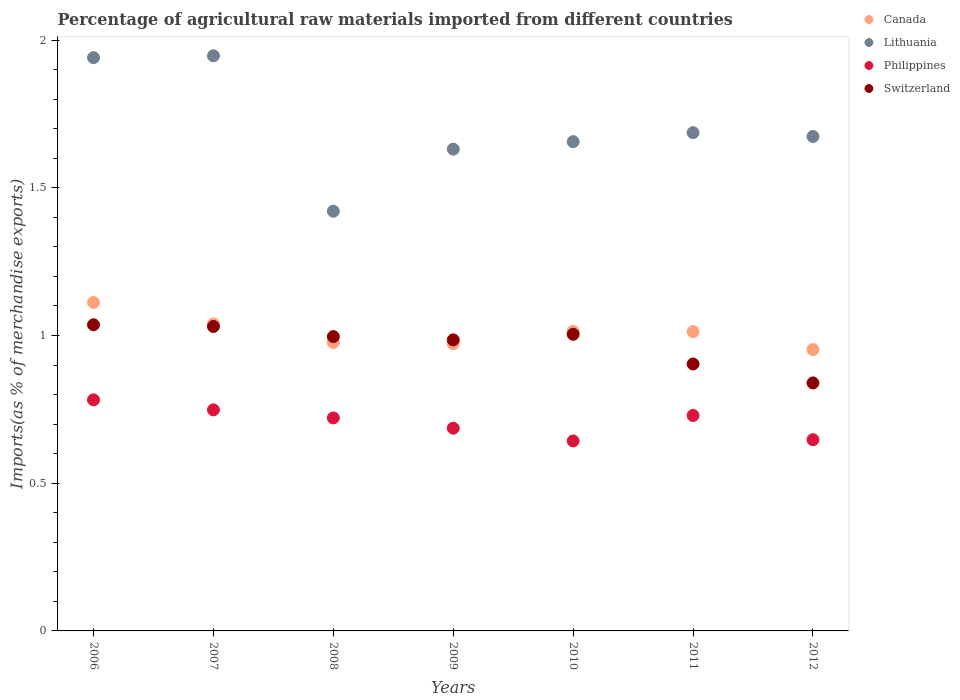How many different coloured dotlines are there?
Your answer should be compact. 4. Is the number of dotlines equal to the number of legend labels?
Provide a short and direct response. Yes. What is the percentage of imports to different countries in Switzerland in 2009?
Your answer should be very brief. 0.99. Across all years, what is the maximum percentage of imports to different countries in Philippines?
Make the answer very short. 0.78. Across all years, what is the minimum percentage of imports to different countries in Lithuania?
Your answer should be very brief. 1.42. In which year was the percentage of imports to different countries in Lithuania maximum?
Provide a short and direct response. 2007. What is the total percentage of imports to different countries in Canada in the graph?
Make the answer very short. 7.08. What is the difference between the percentage of imports to different countries in Lithuania in 2006 and that in 2012?
Provide a short and direct response. 0.27. What is the difference between the percentage of imports to different countries in Switzerland in 2007 and the percentage of imports to different countries in Lithuania in 2008?
Offer a very short reply. -0.39. What is the average percentage of imports to different countries in Philippines per year?
Your answer should be compact. 0.71. In the year 2010, what is the difference between the percentage of imports to different countries in Lithuania and percentage of imports to different countries in Canada?
Provide a succinct answer. 0.64. In how many years, is the percentage of imports to different countries in Canada greater than 1.1 %?
Ensure brevity in your answer.  1. What is the ratio of the percentage of imports to different countries in Canada in 2009 to that in 2010?
Offer a very short reply. 0.96. Is the percentage of imports to different countries in Lithuania in 2011 less than that in 2012?
Your answer should be very brief. No. Is the difference between the percentage of imports to different countries in Lithuania in 2006 and 2010 greater than the difference between the percentage of imports to different countries in Canada in 2006 and 2010?
Keep it short and to the point. Yes. What is the difference between the highest and the second highest percentage of imports to different countries in Switzerland?
Make the answer very short. 0.01. What is the difference between the highest and the lowest percentage of imports to different countries in Philippines?
Your answer should be compact. 0.14. Does the percentage of imports to different countries in Philippines monotonically increase over the years?
Keep it short and to the point. No. Is the percentage of imports to different countries in Philippines strictly less than the percentage of imports to different countries in Switzerland over the years?
Give a very brief answer. Yes. How many dotlines are there?
Your answer should be very brief. 4. How many years are there in the graph?
Keep it short and to the point. 7. What is the difference between two consecutive major ticks on the Y-axis?
Your answer should be compact. 0.5. Are the values on the major ticks of Y-axis written in scientific E-notation?
Provide a succinct answer. No. Does the graph contain any zero values?
Keep it short and to the point. No. Where does the legend appear in the graph?
Provide a succinct answer. Top right. What is the title of the graph?
Offer a terse response. Percentage of agricultural raw materials imported from different countries. Does "Albania" appear as one of the legend labels in the graph?
Your answer should be compact. No. What is the label or title of the Y-axis?
Provide a succinct answer. Imports(as % of merchandise exports). What is the Imports(as % of merchandise exports) in Canada in 2006?
Make the answer very short. 1.11. What is the Imports(as % of merchandise exports) of Lithuania in 2006?
Give a very brief answer. 1.94. What is the Imports(as % of merchandise exports) of Philippines in 2006?
Offer a very short reply. 0.78. What is the Imports(as % of merchandise exports) in Switzerland in 2006?
Offer a terse response. 1.04. What is the Imports(as % of merchandise exports) of Canada in 2007?
Offer a terse response. 1.04. What is the Imports(as % of merchandise exports) of Lithuania in 2007?
Offer a very short reply. 1.95. What is the Imports(as % of merchandise exports) of Philippines in 2007?
Ensure brevity in your answer.  0.75. What is the Imports(as % of merchandise exports) of Switzerland in 2007?
Ensure brevity in your answer.  1.03. What is the Imports(as % of merchandise exports) of Canada in 2008?
Your answer should be compact. 0.98. What is the Imports(as % of merchandise exports) of Lithuania in 2008?
Offer a terse response. 1.42. What is the Imports(as % of merchandise exports) in Philippines in 2008?
Provide a succinct answer. 0.72. What is the Imports(as % of merchandise exports) of Switzerland in 2008?
Your answer should be compact. 1. What is the Imports(as % of merchandise exports) in Canada in 2009?
Your answer should be very brief. 0.97. What is the Imports(as % of merchandise exports) in Lithuania in 2009?
Keep it short and to the point. 1.63. What is the Imports(as % of merchandise exports) of Philippines in 2009?
Provide a succinct answer. 0.69. What is the Imports(as % of merchandise exports) of Switzerland in 2009?
Provide a short and direct response. 0.99. What is the Imports(as % of merchandise exports) in Canada in 2010?
Ensure brevity in your answer.  1.01. What is the Imports(as % of merchandise exports) in Lithuania in 2010?
Make the answer very short. 1.66. What is the Imports(as % of merchandise exports) in Philippines in 2010?
Provide a short and direct response. 0.64. What is the Imports(as % of merchandise exports) in Switzerland in 2010?
Offer a very short reply. 1. What is the Imports(as % of merchandise exports) of Canada in 2011?
Offer a terse response. 1.01. What is the Imports(as % of merchandise exports) in Lithuania in 2011?
Keep it short and to the point. 1.69. What is the Imports(as % of merchandise exports) of Philippines in 2011?
Your response must be concise. 0.73. What is the Imports(as % of merchandise exports) in Switzerland in 2011?
Keep it short and to the point. 0.9. What is the Imports(as % of merchandise exports) of Canada in 2012?
Provide a short and direct response. 0.95. What is the Imports(as % of merchandise exports) of Lithuania in 2012?
Your answer should be very brief. 1.67. What is the Imports(as % of merchandise exports) of Philippines in 2012?
Your response must be concise. 0.65. What is the Imports(as % of merchandise exports) of Switzerland in 2012?
Give a very brief answer. 0.84. Across all years, what is the maximum Imports(as % of merchandise exports) in Canada?
Your answer should be very brief. 1.11. Across all years, what is the maximum Imports(as % of merchandise exports) of Lithuania?
Your answer should be compact. 1.95. Across all years, what is the maximum Imports(as % of merchandise exports) of Philippines?
Provide a succinct answer. 0.78. Across all years, what is the maximum Imports(as % of merchandise exports) in Switzerland?
Offer a very short reply. 1.04. Across all years, what is the minimum Imports(as % of merchandise exports) in Canada?
Offer a terse response. 0.95. Across all years, what is the minimum Imports(as % of merchandise exports) of Lithuania?
Offer a very short reply. 1.42. Across all years, what is the minimum Imports(as % of merchandise exports) of Philippines?
Offer a very short reply. 0.64. Across all years, what is the minimum Imports(as % of merchandise exports) in Switzerland?
Provide a succinct answer. 0.84. What is the total Imports(as % of merchandise exports) in Canada in the graph?
Give a very brief answer. 7.08. What is the total Imports(as % of merchandise exports) in Lithuania in the graph?
Provide a short and direct response. 11.95. What is the total Imports(as % of merchandise exports) in Philippines in the graph?
Keep it short and to the point. 4.96. What is the total Imports(as % of merchandise exports) in Switzerland in the graph?
Your response must be concise. 6.79. What is the difference between the Imports(as % of merchandise exports) in Canada in 2006 and that in 2007?
Provide a short and direct response. 0.07. What is the difference between the Imports(as % of merchandise exports) of Lithuania in 2006 and that in 2007?
Your response must be concise. -0.01. What is the difference between the Imports(as % of merchandise exports) in Philippines in 2006 and that in 2007?
Offer a terse response. 0.03. What is the difference between the Imports(as % of merchandise exports) in Switzerland in 2006 and that in 2007?
Provide a short and direct response. 0.01. What is the difference between the Imports(as % of merchandise exports) of Canada in 2006 and that in 2008?
Keep it short and to the point. 0.14. What is the difference between the Imports(as % of merchandise exports) in Lithuania in 2006 and that in 2008?
Offer a very short reply. 0.52. What is the difference between the Imports(as % of merchandise exports) of Philippines in 2006 and that in 2008?
Offer a very short reply. 0.06. What is the difference between the Imports(as % of merchandise exports) in Switzerland in 2006 and that in 2008?
Make the answer very short. 0.04. What is the difference between the Imports(as % of merchandise exports) of Canada in 2006 and that in 2009?
Keep it short and to the point. 0.14. What is the difference between the Imports(as % of merchandise exports) in Lithuania in 2006 and that in 2009?
Offer a very short reply. 0.31. What is the difference between the Imports(as % of merchandise exports) in Philippines in 2006 and that in 2009?
Your response must be concise. 0.1. What is the difference between the Imports(as % of merchandise exports) of Switzerland in 2006 and that in 2009?
Offer a very short reply. 0.05. What is the difference between the Imports(as % of merchandise exports) of Canada in 2006 and that in 2010?
Your answer should be compact. 0.1. What is the difference between the Imports(as % of merchandise exports) of Lithuania in 2006 and that in 2010?
Provide a succinct answer. 0.28. What is the difference between the Imports(as % of merchandise exports) in Philippines in 2006 and that in 2010?
Keep it short and to the point. 0.14. What is the difference between the Imports(as % of merchandise exports) in Switzerland in 2006 and that in 2010?
Your response must be concise. 0.03. What is the difference between the Imports(as % of merchandise exports) in Canada in 2006 and that in 2011?
Your response must be concise. 0.1. What is the difference between the Imports(as % of merchandise exports) in Lithuania in 2006 and that in 2011?
Offer a very short reply. 0.25. What is the difference between the Imports(as % of merchandise exports) in Philippines in 2006 and that in 2011?
Provide a succinct answer. 0.05. What is the difference between the Imports(as % of merchandise exports) of Switzerland in 2006 and that in 2011?
Offer a very short reply. 0.13. What is the difference between the Imports(as % of merchandise exports) of Canada in 2006 and that in 2012?
Give a very brief answer. 0.16. What is the difference between the Imports(as % of merchandise exports) in Lithuania in 2006 and that in 2012?
Your answer should be very brief. 0.27. What is the difference between the Imports(as % of merchandise exports) in Philippines in 2006 and that in 2012?
Offer a very short reply. 0.13. What is the difference between the Imports(as % of merchandise exports) of Switzerland in 2006 and that in 2012?
Your answer should be compact. 0.2. What is the difference between the Imports(as % of merchandise exports) in Canada in 2007 and that in 2008?
Offer a very short reply. 0.06. What is the difference between the Imports(as % of merchandise exports) in Lithuania in 2007 and that in 2008?
Give a very brief answer. 0.53. What is the difference between the Imports(as % of merchandise exports) in Philippines in 2007 and that in 2008?
Provide a succinct answer. 0.03. What is the difference between the Imports(as % of merchandise exports) in Switzerland in 2007 and that in 2008?
Your answer should be very brief. 0.03. What is the difference between the Imports(as % of merchandise exports) in Canada in 2007 and that in 2009?
Your response must be concise. 0.07. What is the difference between the Imports(as % of merchandise exports) in Lithuania in 2007 and that in 2009?
Offer a terse response. 0.32. What is the difference between the Imports(as % of merchandise exports) of Philippines in 2007 and that in 2009?
Offer a terse response. 0.06. What is the difference between the Imports(as % of merchandise exports) in Switzerland in 2007 and that in 2009?
Provide a short and direct response. 0.05. What is the difference between the Imports(as % of merchandise exports) of Canada in 2007 and that in 2010?
Make the answer very short. 0.03. What is the difference between the Imports(as % of merchandise exports) in Lithuania in 2007 and that in 2010?
Your response must be concise. 0.29. What is the difference between the Imports(as % of merchandise exports) of Philippines in 2007 and that in 2010?
Give a very brief answer. 0.11. What is the difference between the Imports(as % of merchandise exports) of Switzerland in 2007 and that in 2010?
Offer a very short reply. 0.03. What is the difference between the Imports(as % of merchandise exports) in Canada in 2007 and that in 2011?
Provide a succinct answer. 0.03. What is the difference between the Imports(as % of merchandise exports) in Lithuania in 2007 and that in 2011?
Make the answer very short. 0.26. What is the difference between the Imports(as % of merchandise exports) in Philippines in 2007 and that in 2011?
Offer a very short reply. 0.02. What is the difference between the Imports(as % of merchandise exports) of Switzerland in 2007 and that in 2011?
Offer a terse response. 0.13. What is the difference between the Imports(as % of merchandise exports) of Canada in 2007 and that in 2012?
Provide a short and direct response. 0.09. What is the difference between the Imports(as % of merchandise exports) in Lithuania in 2007 and that in 2012?
Keep it short and to the point. 0.27. What is the difference between the Imports(as % of merchandise exports) of Philippines in 2007 and that in 2012?
Your response must be concise. 0.1. What is the difference between the Imports(as % of merchandise exports) of Switzerland in 2007 and that in 2012?
Your response must be concise. 0.19. What is the difference between the Imports(as % of merchandise exports) of Canada in 2008 and that in 2009?
Provide a succinct answer. 0. What is the difference between the Imports(as % of merchandise exports) in Lithuania in 2008 and that in 2009?
Your response must be concise. -0.21. What is the difference between the Imports(as % of merchandise exports) of Philippines in 2008 and that in 2009?
Keep it short and to the point. 0.03. What is the difference between the Imports(as % of merchandise exports) in Switzerland in 2008 and that in 2009?
Ensure brevity in your answer.  0.01. What is the difference between the Imports(as % of merchandise exports) in Canada in 2008 and that in 2010?
Your answer should be very brief. -0.04. What is the difference between the Imports(as % of merchandise exports) in Lithuania in 2008 and that in 2010?
Make the answer very short. -0.24. What is the difference between the Imports(as % of merchandise exports) of Philippines in 2008 and that in 2010?
Ensure brevity in your answer.  0.08. What is the difference between the Imports(as % of merchandise exports) in Switzerland in 2008 and that in 2010?
Offer a very short reply. -0.01. What is the difference between the Imports(as % of merchandise exports) in Canada in 2008 and that in 2011?
Provide a succinct answer. -0.04. What is the difference between the Imports(as % of merchandise exports) of Lithuania in 2008 and that in 2011?
Offer a terse response. -0.27. What is the difference between the Imports(as % of merchandise exports) of Philippines in 2008 and that in 2011?
Make the answer very short. -0.01. What is the difference between the Imports(as % of merchandise exports) in Switzerland in 2008 and that in 2011?
Provide a short and direct response. 0.09. What is the difference between the Imports(as % of merchandise exports) of Canada in 2008 and that in 2012?
Your answer should be very brief. 0.02. What is the difference between the Imports(as % of merchandise exports) of Lithuania in 2008 and that in 2012?
Offer a very short reply. -0.25. What is the difference between the Imports(as % of merchandise exports) of Philippines in 2008 and that in 2012?
Give a very brief answer. 0.07. What is the difference between the Imports(as % of merchandise exports) in Switzerland in 2008 and that in 2012?
Give a very brief answer. 0.16. What is the difference between the Imports(as % of merchandise exports) in Canada in 2009 and that in 2010?
Your response must be concise. -0.04. What is the difference between the Imports(as % of merchandise exports) in Lithuania in 2009 and that in 2010?
Ensure brevity in your answer.  -0.03. What is the difference between the Imports(as % of merchandise exports) in Philippines in 2009 and that in 2010?
Keep it short and to the point. 0.04. What is the difference between the Imports(as % of merchandise exports) of Switzerland in 2009 and that in 2010?
Offer a very short reply. -0.02. What is the difference between the Imports(as % of merchandise exports) of Canada in 2009 and that in 2011?
Your response must be concise. -0.04. What is the difference between the Imports(as % of merchandise exports) of Lithuania in 2009 and that in 2011?
Provide a short and direct response. -0.06. What is the difference between the Imports(as % of merchandise exports) in Philippines in 2009 and that in 2011?
Make the answer very short. -0.04. What is the difference between the Imports(as % of merchandise exports) of Switzerland in 2009 and that in 2011?
Ensure brevity in your answer.  0.08. What is the difference between the Imports(as % of merchandise exports) in Lithuania in 2009 and that in 2012?
Give a very brief answer. -0.04. What is the difference between the Imports(as % of merchandise exports) of Philippines in 2009 and that in 2012?
Make the answer very short. 0.04. What is the difference between the Imports(as % of merchandise exports) in Switzerland in 2009 and that in 2012?
Offer a very short reply. 0.15. What is the difference between the Imports(as % of merchandise exports) of Lithuania in 2010 and that in 2011?
Provide a succinct answer. -0.03. What is the difference between the Imports(as % of merchandise exports) in Philippines in 2010 and that in 2011?
Give a very brief answer. -0.09. What is the difference between the Imports(as % of merchandise exports) in Switzerland in 2010 and that in 2011?
Provide a short and direct response. 0.1. What is the difference between the Imports(as % of merchandise exports) of Canada in 2010 and that in 2012?
Your response must be concise. 0.06. What is the difference between the Imports(as % of merchandise exports) of Lithuania in 2010 and that in 2012?
Your response must be concise. -0.02. What is the difference between the Imports(as % of merchandise exports) in Philippines in 2010 and that in 2012?
Ensure brevity in your answer.  -0. What is the difference between the Imports(as % of merchandise exports) of Switzerland in 2010 and that in 2012?
Offer a very short reply. 0.16. What is the difference between the Imports(as % of merchandise exports) of Canada in 2011 and that in 2012?
Offer a terse response. 0.06. What is the difference between the Imports(as % of merchandise exports) of Lithuania in 2011 and that in 2012?
Provide a succinct answer. 0.01. What is the difference between the Imports(as % of merchandise exports) of Philippines in 2011 and that in 2012?
Give a very brief answer. 0.08. What is the difference between the Imports(as % of merchandise exports) of Switzerland in 2011 and that in 2012?
Your answer should be very brief. 0.06. What is the difference between the Imports(as % of merchandise exports) in Canada in 2006 and the Imports(as % of merchandise exports) in Lithuania in 2007?
Offer a terse response. -0.83. What is the difference between the Imports(as % of merchandise exports) of Canada in 2006 and the Imports(as % of merchandise exports) of Philippines in 2007?
Keep it short and to the point. 0.36. What is the difference between the Imports(as % of merchandise exports) in Canada in 2006 and the Imports(as % of merchandise exports) in Switzerland in 2007?
Your answer should be very brief. 0.08. What is the difference between the Imports(as % of merchandise exports) of Lithuania in 2006 and the Imports(as % of merchandise exports) of Philippines in 2007?
Keep it short and to the point. 1.19. What is the difference between the Imports(as % of merchandise exports) in Lithuania in 2006 and the Imports(as % of merchandise exports) in Switzerland in 2007?
Ensure brevity in your answer.  0.91. What is the difference between the Imports(as % of merchandise exports) in Philippines in 2006 and the Imports(as % of merchandise exports) in Switzerland in 2007?
Make the answer very short. -0.25. What is the difference between the Imports(as % of merchandise exports) in Canada in 2006 and the Imports(as % of merchandise exports) in Lithuania in 2008?
Keep it short and to the point. -0.31. What is the difference between the Imports(as % of merchandise exports) of Canada in 2006 and the Imports(as % of merchandise exports) of Philippines in 2008?
Your response must be concise. 0.39. What is the difference between the Imports(as % of merchandise exports) of Canada in 2006 and the Imports(as % of merchandise exports) of Switzerland in 2008?
Keep it short and to the point. 0.12. What is the difference between the Imports(as % of merchandise exports) in Lithuania in 2006 and the Imports(as % of merchandise exports) in Philippines in 2008?
Give a very brief answer. 1.22. What is the difference between the Imports(as % of merchandise exports) of Lithuania in 2006 and the Imports(as % of merchandise exports) of Switzerland in 2008?
Make the answer very short. 0.94. What is the difference between the Imports(as % of merchandise exports) of Philippines in 2006 and the Imports(as % of merchandise exports) of Switzerland in 2008?
Provide a succinct answer. -0.21. What is the difference between the Imports(as % of merchandise exports) in Canada in 2006 and the Imports(as % of merchandise exports) in Lithuania in 2009?
Make the answer very short. -0.52. What is the difference between the Imports(as % of merchandise exports) in Canada in 2006 and the Imports(as % of merchandise exports) in Philippines in 2009?
Your response must be concise. 0.43. What is the difference between the Imports(as % of merchandise exports) of Canada in 2006 and the Imports(as % of merchandise exports) of Switzerland in 2009?
Offer a terse response. 0.13. What is the difference between the Imports(as % of merchandise exports) in Lithuania in 2006 and the Imports(as % of merchandise exports) in Philippines in 2009?
Your response must be concise. 1.25. What is the difference between the Imports(as % of merchandise exports) in Lithuania in 2006 and the Imports(as % of merchandise exports) in Switzerland in 2009?
Offer a very short reply. 0.96. What is the difference between the Imports(as % of merchandise exports) in Philippines in 2006 and the Imports(as % of merchandise exports) in Switzerland in 2009?
Your response must be concise. -0.2. What is the difference between the Imports(as % of merchandise exports) of Canada in 2006 and the Imports(as % of merchandise exports) of Lithuania in 2010?
Provide a succinct answer. -0.54. What is the difference between the Imports(as % of merchandise exports) in Canada in 2006 and the Imports(as % of merchandise exports) in Philippines in 2010?
Provide a succinct answer. 0.47. What is the difference between the Imports(as % of merchandise exports) in Canada in 2006 and the Imports(as % of merchandise exports) in Switzerland in 2010?
Your response must be concise. 0.11. What is the difference between the Imports(as % of merchandise exports) of Lithuania in 2006 and the Imports(as % of merchandise exports) of Philippines in 2010?
Ensure brevity in your answer.  1.3. What is the difference between the Imports(as % of merchandise exports) of Lithuania in 2006 and the Imports(as % of merchandise exports) of Switzerland in 2010?
Provide a short and direct response. 0.94. What is the difference between the Imports(as % of merchandise exports) of Philippines in 2006 and the Imports(as % of merchandise exports) of Switzerland in 2010?
Your answer should be very brief. -0.22. What is the difference between the Imports(as % of merchandise exports) in Canada in 2006 and the Imports(as % of merchandise exports) in Lithuania in 2011?
Ensure brevity in your answer.  -0.57. What is the difference between the Imports(as % of merchandise exports) of Canada in 2006 and the Imports(as % of merchandise exports) of Philippines in 2011?
Provide a succinct answer. 0.38. What is the difference between the Imports(as % of merchandise exports) of Canada in 2006 and the Imports(as % of merchandise exports) of Switzerland in 2011?
Your response must be concise. 0.21. What is the difference between the Imports(as % of merchandise exports) in Lithuania in 2006 and the Imports(as % of merchandise exports) in Philippines in 2011?
Your answer should be compact. 1.21. What is the difference between the Imports(as % of merchandise exports) of Lithuania in 2006 and the Imports(as % of merchandise exports) of Switzerland in 2011?
Provide a succinct answer. 1.04. What is the difference between the Imports(as % of merchandise exports) in Philippines in 2006 and the Imports(as % of merchandise exports) in Switzerland in 2011?
Your answer should be compact. -0.12. What is the difference between the Imports(as % of merchandise exports) of Canada in 2006 and the Imports(as % of merchandise exports) of Lithuania in 2012?
Your answer should be very brief. -0.56. What is the difference between the Imports(as % of merchandise exports) in Canada in 2006 and the Imports(as % of merchandise exports) in Philippines in 2012?
Your answer should be very brief. 0.46. What is the difference between the Imports(as % of merchandise exports) in Canada in 2006 and the Imports(as % of merchandise exports) in Switzerland in 2012?
Make the answer very short. 0.27. What is the difference between the Imports(as % of merchandise exports) of Lithuania in 2006 and the Imports(as % of merchandise exports) of Philippines in 2012?
Offer a terse response. 1.29. What is the difference between the Imports(as % of merchandise exports) in Lithuania in 2006 and the Imports(as % of merchandise exports) in Switzerland in 2012?
Make the answer very short. 1.1. What is the difference between the Imports(as % of merchandise exports) in Philippines in 2006 and the Imports(as % of merchandise exports) in Switzerland in 2012?
Provide a short and direct response. -0.06. What is the difference between the Imports(as % of merchandise exports) in Canada in 2007 and the Imports(as % of merchandise exports) in Lithuania in 2008?
Your answer should be very brief. -0.38. What is the difference between the Imports(as % of merchandise exports) in Canada in 2007 and the Imports(as % of merchandise exports) in Philippines in 2008?
Provide a short and direct response. 0.32. What is the difference between the Imports(as % of merchandise exports) in Canada in 2007 and the Imports(as % of merchandise exports) in Switzerland in 2008?
Your answer should be compact. 0.04. What is the difference between the Imports(as % of merchandise exports) of Lithuania in 2007 and the Imports(as % of merchandise exports) of Philippines in 2008?
Provide a succinct answer. 1.23. What is the difference between the Imports(as % of merchandise exports) in Lithuania in 2007 and the Imports(as % of merchandise exports) in Switzerland in 2008?
Ensure brevity in your answer.  0.95. What is the difference between the Imports(as % of merchandise exports) of Philippines in 2007 and the Imports(as % of merchandise exports) of Switzerland in 2008?
Provide a succinct answer. -0.25. What is the difference between the Imports(as % of merchandise exports) in Canada in 2007 and the Imports(as % of merchandise exports) in Lithuania in 2009?
Your answer should be compact. -0.59. What is the difference between the Imports(as % of merchandise exports) in Canada in 2007 and the Imports(as % of merchandise exports) in Philippines in 2009?
Make the answer very short. 0.35. What is the difference between the Imports(as % of merchandise exports) in Canada in 2007 and the Imports(as % of merchandise exports) in Switzerland in 2009?
Your answer should be compact. 0.05. What is the difference between the Imports(as % of merchandise exports) in Lithuania in 2007 and the Imports(as % of merchandise exports) in Philippines in 2009?
Offer a terse response. 1.26. What is the difference between the Imports(as % of merchandise exports) of Lithuania in 2007 and the Imports(as % of merchandise exports) of Switzerland in 2009?
Give a very brief answer. 0.96. What is the difference between the Imports(as % of merchandise exports) in Philippines in 2007 and the Imports(as % of merchandise exports) in Switzerland in 2009?
Offer a very short reply. -0.24. What is the difference between the Imports(as % of merchandise exports) in Canada in 2007 and the Imports(as % of merchandise exports) in Lithuania in 2010?
Offer a terse response. -0.62. What is the difference between the Imports(as % of merchandise exports) in Canada in 2007 and the Imports(as % of merchandise exports) in Philippines in 2010?
Your response must be concise. 0.4. What is the difference between the Imports(as % of merchandise exports) of Canada in 2007 and the Imports(as % of merchandise exports) of Switzerland in 2010?
Ensure brevity in your answer.  0.04. What is the difference between the Imports(as % of merchandise exports) of Lithuania in 2007 and the Imports(as % of merchandise exports) of Philippines in 2010?
Provide a succinct answer. 1.3. What is the difference between the Imports(as % of merchandise exports) of Lithuania in 2007 and the Imports(as % of merchandise exports) of Switzerland in 2010?
Make the answer very short. 0.94. What is the difference between the Imports(as % of merchandise exports) in Philippines in 2007 and the Imports(as % of merchandise exports) in Switzerland in 2010?
Your response must be concise. -0.26. What is the difference between the Imports(as % of merchandise exports) of Canada in 2007 and the Imports(as % of merchandise exports) of Lithuania in 2011?
Your response must be concise. -0.65. What is the difference between the Imports(as % of merchandise exports) in Canada in 2007 and the Imports(as % of merchandise exports) in Philippines in 2011?
Offer a terse response. 0.31. What is the difference between the Imports(as % of merchandise exports) of Canada in 2007 and the Imports(as % of merchandise exports) of Switzerland in 2011?
Offer a very short reply. 0.14. What is the difference between the Imports(as % of merchandise exports) in Lithuania in 2007 and the Imports(as % of merchandise exports) in Philippines in 2011?
Offer a very short reply. 1.22. What is the difference between the Imports(as % of merchandise exports) in Lithuania in 2007 and the Imports(as % of merchandise exports) in Switzerland in 2011?
Your answer should be compact. 1.04. What is the difference between the Imports(as % of merchandise exports) of Philippines in 2007 and the Imports(as % of merchandise exports) of Switzerland in 2011?
Offer a very short reply. -0.16. What is the difference between the Imports(as % of merchandise exports) in Canada in 2007 and the Imports(as % of merchandise exports) in Lithuania in 2012?
Provide a succinct answer. -0.63. What is the difference between the Imports(as % of merchandise exports) in Canada in 2007 and the Imports(as % of merchandise exports) in Philippines in 2012?
Offer a very short reply. 0.39. What is the difference between the Imports(as % of merchandise exports) in Canada in 2007 and the Imports(as % of merchandise exports) in Switzerland in 2012?
Provide a succinct answer. 0.2. What is the difference between the Imports(as % of merchandise exports) of Lithuania in 2007 and the Imports(as % of merchandise exports) of Philippines in 2012?
Keep it short and to the point. 1.3. What is the difference between the Imports(as % of merchandise exports) of Lithuania in 2007 and the Imports(as % of merchandise exports) of Switzerland in 2012?
Provide a succinct answer. 1.11. What is the difference between the Imports(as % of merchandise exports) of Philippines in 2007 and the Imports(as % of merchandise exports) of Switzerland in 2012?
Your response must be concise. -0.09. What is the difference between the Imports(as % of merchandise exports) in Canada in 2008 and the Imports(as % of merchandise exports) in Lithuania in 2009?
Provide a short and direct response. -0.65. What is the difference between the Imports(as % of merchandise exports) in Canada in 2008 and the Imports(as % of merchandise exports) in Philippines in 2009?
Provide a succinct answer. 0.29. What is the difference between the Imports(as % of merchandise exports) in Canada in 2008 and the Imports(as % of merchandise exports) in Switzerland in 2009?
Offer a terse response. -0.01. What is the difference between the Imports(as % of merchandise exports) in Lithuania in 2008 and the Imports(as % of merchandise exports) in Philippines in 2009?
Provide a short and direct response. 0.73. What is the difference between the Imports(as % of merchandise exports) in Lithuania in 2008 and the Imports(as % of merchandise exports) in Switzerland in 2009?
Offer a terse response. 0.44. What is the difference between the Imports(as % of merchandise exports) of Philippines in 2008 and the Imports(as % of merchandise exports) of Switzerland in 2009?
Provide a short and direct response. -0.26. What is the difference between the Imports(as % of merchandise exports) of Canada in 2008 and the Imports(as % of merchandise exports) of Lithuania in 2010?
Ensure brevity in your answer.  -0.68. What is the difference between the Imports(as % of merchandise exports) in Canada in 2008 and the Imports(as % of merchandise exports) in Switzerland in 2010?
Ensure brevity in your answer.  -0.03. What is the difference between the Imports(as % of merchandise exports) in Lithuania in 2008 and the Imports(as % of merchandise exports) in Philippines in 2010?
Give a very brief answer. 0.78. What is the difference between the Imports(as % of merchandise exports) of Lithuania in 2008 and the Imports(as % of merchandise exports) of Switzerland in 2010?
Provide a short and direct response. 0.42. What is the difference between the Imports(as % of merchandise exports) of Philippines in 2008 and the Imports(as % of merchandise exports) of Switzerland in 2010?
Make the answer very short. -0.28. What is the difference between the Imports(as % of merchandise exports) of Canada in 2008 and the Imports(as % of merchandise exports) of Lithuania in 2011?
Offer a very short reply. -0.71. What is the difference between the Imports(as % of merchandise exports) of Canada in 2008 and the Imports(as % of merchandise exports) of Philippines in 2011?
Give a very brief answer. 0.25. What is the difference between the Imports(as % of merchandise exports) in Canada in 2008 and the Imports(as % of merchandise exports) in Switzerland in 2011?
Offer a terse response. 0.07. What is the difference between the Imports(as % of merchandise exports) of Lithuania in 2008 and the Imports(as % of merchandise exports) of Philippines in 2011?
Your response must be concise. 0.69. What is the difference between the Imports(as % of merchandise exports) of Lithuania in 2008 and the Imports(as % of merchandise exports) of Switzerland in 2011?
Offer a terse response. 0.52. What is the difference between the Imports(as % of merchandise exports) in Philippines in 2008 and the Imports(as % of merchandise exports) in Switzerland in 2011?
Keep it short and to the point. -0.18. What is the difference between the Imports(as % of merchandise exports) of Canada in 2008 and the Imports(as % of merchandise exports) of Lithuania in 2012?
Ensure brevity in your answer.  -0.7. What is the difference between the Imports(as % of merchandise exports) in Canada in 2008 and the Imports(as % of merchandise exports) in Philippines in 2012?
Give a very brief answer. 0.33. What is the difference between the Imports(as % of merchandise exports) in Canada in 2008 and the Imports(as % of merchandise exports) in Switzerland in 2012?
Provide a succinct answer. 0.14. What is the difference between the Imports(as % of merchandise exports) in Lithuania in 2008 and the Imports(as % of merchandise exports) in Philippines in 2012?
Offer a very short reply. 0.77. What is the difference between the Imports(as % of merchandise exports) in Lithuania in 2008 and the Imports(as % of merchandise exports) in Switzerland in 2012?
Your answer should be very brief. 0.58. What is the difference between the Imports(as % of merchandise exports) of Philippines in 2008 and the Imports(as % of merchandise exports) of Switzerland in 2012?
Give a very brief answer. -0.12. What is the difference between the Imports(as % of merchandise exports) in Canada in 2009 and the Imports(as % of merchandise exports) in Lithuania in 2010?
Ensure brevity in your answer.  -0.68. What is the difference between the Imports(as % of merchandise exports) of Canada in 2009 and the Imports(as % of merchandise exports) of Philippines in 2010?
Offer a terse response. 0.33. What is the difference between the Imports(as % of merchandise exports) of Canada in 2009 and the Imports(as % of merchandise exports) of Switzerland in 2010?
Provide a succinct answer. -0.03. What is the difference between the Imports(as % of merchandise exports) in Lithuania in 2009 and the Imports(as % of merchandise exports) in Switzerland in 2010?
Give a very brief answer. 0.63. What is the difference between the Imports(as % of merchandise exports) of Philippines in 2009 and the Imports(as % of merchandise exports) of Switzerland in 2010?
Your response must be concise. -0.32. What is the difference between the Imports(as % of merchandise exports) in Canada in 2009 and the Imports(as % of merchandise exports) in Lithuania in 2011?
Make the answer very short. -0.71. What is the difference between the Imports(as % of merchandise exports) of Canada in 2009 and the Imports(as % of merchandise exports) of Philippines in 2011?
Give a very brief answer. 0.24. What is the difference between the Imports(as % of merchandise exports) in Canada in 2009 and the Imports(as % of merchandise exports) in Switzerland in 2011?
Ensure brevity in your answer.  0.07. What is the difference between the Imports(as % of merchandise exports) of Lithuania in 2009 and the Imports(as % of merchandise exports) of Philippines in 2011?
Ensure brevity in your answer.  0.9. What is the difference between the Imports(as % of merchandise exports) in Lithuania in 2009 and the Imports(as % of merchandise exports) in Switzerland in 2011?
Keep it short and to the point. 0.73. What is the difference between the Imports(as % of merchandise exports) of Philippines in 2009 and the Imports(as % of merchandise exports) of Switzerland in 2011?
Make the answer very short. -0.22. What is the difference between the Imports(as % of merchandise exports) of Canada in 2009 and the Imports(as % of merchandise exports) of Lithuania in 2012?
Offer a terse response. -0.7. What is the difference between the Imports(as % of merchandise exports) of Canada in 2009 and the Imports(as % of merchandise exports) of Philippines in 2012?
Ensure brevity in your answer.  0.33. What is the difference between the Imports(as % of merchandise exports) of Canada in 2009 and the Imports(as % of merchandise exports) of Switzerland in 2012?
Provide a succinct answer. 0.13. What is the difference between the Imports(as % of merchandise exports) of Lithuania in 2009 and the Imports(as % of merchandise exports) of Philippines in 2012?
Provide a short and direct response. 0.98. What is the difference between the Imports(as % of merchandise exports) of Lithuania in 2009 and the Imports(as % of merchandise exports) of Switzerland in 2012?
Provide a short and direct response. 0.79. What is the difference between the Imports(as % of merchandise exports) in Philippines in 2009 and the Imports(as % of merchandise exports) in Switzerland in 2012?
Your answer should be compact. -0.15. What is the difference between the Imports(as % of merchandise exports) in Canada in 2010 and the Imports(as % of merchandise exports) in Lithuania in 2011?
Your answer should be compact. -0.67. What is the difference between the Imports(as % of merchandise exports) in Canada in 2010 and the Imports(as % of merchandise exports) in Philippines in 2011?
Provide a succinct answer. 0.28. What is the difference between the Imports(as % of merchandise exports) of Canada in 2010 and the Imports(as % of merchandise exports) of Switzerland in 2011?
Make the answer very short. 0.11. What is the difference between the Imports(as % of merchandise exports) of Lithuania in 2010 and the Imports(as % of merchandise exports) of Philippines in 2011?
Your response must be concise. 0.93. What is the difference between the Imports(as % of merchandise exports) in Lithuania in 2010 and the Imports(as % of merchandise exports) in Switzerland in 2011?
Offer a terse response. 0.75. What is the difference between the Imports(as % of merchandise exports) of Philippines in 2010 and the Imports(as % of merchandise exports) of Switzerland in 2011?
Make the answer very short. -0.26. What is the difference between the Imports(as % of merchandise exports) of Canada in 2010 and the Imports(as % of merchandise exports) of Lithuania in 2012?
Your answer should be compact. -0.66. What is the difference between the Imports(as % of merchandise exports) in Canada in 2010 and the Imports(as % of merchandise exports) in Philippines in 2012?
Your response must be concise. 0.37. What is the difference between the Imports(as % of merchandise exports) in Canada in 2010 and the Imports(as % of merchandise exports) in Switzerland in 2012?
Your answer should be very brief. 0.17. What is the difference between the Imports(as % of merchandise exports) of Lithuania in 2010 and the Imports(as % of merchandise exports) of Philippines in 2012?
Offer a very short reply. 1.01. What is the difference between the Imports(as % of merchandise exports) of Lithuania in 2010 and the Imports(as % of merchandise exports) of Switzerland in 2012?
Your answer should be compact. 0.82. What is the difference between the Imports(as % of merchandise exports) of Philippines in 2010 and the Imports(as % of merchandise exports) of Switzerland in 2012?
Offer a terse response. -0.2. What is the difference between the Imports(as % of merchandise exports) of Canada in 2011 and the Imports(as % of merchandise exports) of Lithuania in 2012?
Ensure brevity in your answer.  -0.66. What is the difference between the Imports(as % of merchandise exports) of Canada in 2011 and the Imports(as % of merchandise exports) of Philippines in 2012?
Offer a very short reply. 0.37. What is the difference between the Imports(as % of merchandise exports) in Canada in 2011 and the Imports(as % of merchandise exports) in Switzerland in 2012?
Offer a terse response. 0.17. What is the difference between the Imports(as % of merchandise exports) of Lithuania in 2011 and the Imports(as % of merchandise exports) of Philippines in 2012?
Provide a short and direct response. 1.04. What is the difference between the Imports(as % of merchandise exports) of Lithuania in 2011 and the Imports(as % of merchandise exports) of Switzerland in 2012?
Give a very brief answer. 0.85. What is the difference between the Imports(as % of merchandise exports) of Philippines in 2011 and the Imports(as % of merchandise exports) of Switzerland in 2012?
Your response must be concise. -0.11. What is the average Imports(as % of merchandise exports) of Canada per year?
Provide a short and direct response. 1.01. What is the average Imports(as % of merchandise exports) in Lithuania per year?
Provide a short and direct response. 1.71. What is the average Imports(as % of merchandise exports) of Philippines per year?
Ensure brevity in your answer.  0.71. What is the average Imports(as % of merchandise exports) of Switzerland per year?
Your answer should be very brief. 0.97. In the year 2006, what is the difference between the Imports(as % of merchandise exports) of Canada and Imports(as % of merchandise exports) of Lithuania?
Make the answer very short. -0.83. In the year 2006, what is the difference between the Imports(as % of merchandise exports) in Canada and Imports(as % of merchandise exports) in Philippines?
Give a very brief answer. 0.33. In the year 2006, what is the difference between the Imports(as % of merchandise exports) in Canada and Imports(as % of merchandise exports) in Switzerland?
Offer a terse response. 0.08. In the year 2006, what is the difference between the Imports(as % of merchandise exports) in Lithuania and Imports(as % of merchandise exports) in Philippines?
Ensure brevity in your answer.  1.16. In the year 2006, what is the difference between the Imports(as % of merchandise exports) in Lithuania and Imports(as % of merchandise exports) in Switzerland?
Keep it short and to the point. 0.9. In the year 2006, what is the difference between the Imports(as % of merchandise exports) in Philippines and Imports(as % of merchandise exports) in Switzerland?
Offer a very short reply. -0.25. In the year 2007, what is the difference between the Imports(as % of merchandise exports) of Canada and Imports(as % of merchandise exports) of Lithuania?
Give a very brief answer. -0.91. In the year 2007, what is the difference between the Imports(as % of merchandise exports) of Canada and Imports(as % of merchandise exports) of Philippines?
Your answer should be very brief. 0.29. In the year 2007, what is the difference between the Imports(as % of merchandise exports) of Canada and Imports(as % of merchandise exports) of Switzerland?
Provide a succinct answer. 0.01. In the year 2007, what is the difference between the Imports(as % of merchandise exports) of Lithuania and Imports(as % of merchandise exports) of Philippines?
Your answer should be very brief. 1.2. In the year 2007, what is the difference between the Imports(as % of merchandise exports) of Lithuania and Imports(as % of merchandise exports) of Switzerland?
Your answer should be compact. 0.92. In the year 2007, what is the difference between the Imports(as % of merchandise exports) of Philippines and Imports(as % of merchandise exports) of Switzerland?
Provide a succinct answer. -0.28. In the year 2008, what is the difference between the Imports(as % of merchandise exports) of Canada and Imports(as % of merchandise exports) of Lithuania?
Offer a terse response. -0.44. In the year 2008, what is the difference between the Imports(as % of merchandise exports) of Canada and Imports(as % of merchandise exports) of Philippines?
Provide a short and direct response. 0.26. In the year 2008, what is the difference between the Imports(as % of merchandise exports) of Canada and Imports(as % of merchandise exports) of Switzerland?
Keep it short and to the point. -0.02. In the year 2008, what is the difference between the Imports(as % of merchandise exports) of Lithuania and Imports(as % of merchandise exports) of Philippines?
Offer a very short reply. 0.7. In the year 2008, what is the difference between the Imports(as % of merchandise exports) in Lithuania and Imports(as % of merchandise exports) in Switzerland?
Provide a short and direct response. 0.42. In the year 2008, what is the difference between the Imports(as % of merchandise exports) of Philippines and Imports(as % of merchandise exports) of Switzerland?
Your response must be concise. -0.28. In the year 2009, what is the difference between the Imports(as % of merchandise exports) in Canada and Imports(as % of merchandise exports) in Lithuania?
Offer a very short reply. -0.66. In the year 2009, what is the difference between the Imports(as % of merchandise exports) of Canada and Imports(as % of merchandise exports) of Philippines?
Give a very brief answer. 0.29. In the year 2009, what is the difference between the Imports(as % of merchandise exports) in Canada and Imports(as % of merchandise exports) in Switzerland?
Ensure brevity in your answer.  -0.01. In the year 2009, what is the difference between the Imports(as % of merchandise exports) of Lithuania and Imports(as % of merchandise exports) of Philippines?
Your answer should be very brief. 0.94. In the year 2009, what is the difference between the Imports(as % of merchandise exports) in Lithuania and Imports(as % of merchandise exports) in Switzerland?
Offer a terse response. 0.65. In the year 2009, what is the difference between the Imports(as % of merchandise exports) of Philippines and Imports(as % of merchandise exports) of Switzerland?
Offer a very short reply. -0.3. In the year 2010, what is the difference between the Imports(as % of merchandise exports) in Canada and Imports(as % of merchandise exports) in Lithuania?
Ensure brevity in your answer.  -0.64. In the year 2010, what is the difference between the Imports(as % of merchandise exports) of Canada and Imports(as % of merchandise exports) of Philippines?
Keep it short and to the point. 0.37. In the year 2010, what is the difference between the Imports(as % of merchandise exports) in Canada and Imports(as % of merchandise exports) in Switzerland?
Ensure brevity in your answer.  0.01. In the year 2010, what is the difference between the Imports(as % of merchandise exports) in Lithuania and Imports(as % of merchandise exports) in Switzerland?
Provide a short and direct response. 0.65. In the year 2010, what is the difference between the Imports(as % of merchandise exports) in Philippines and Imports(as % of merchandise exports) in Switzerland?
Provide a short and direct response. -0.36. In the year 2011, what is the difference between the Imports(as % of merchandise exports) in Canada and Imports(as % of merchandise exports) in Lithuania?
Give a very brief answer. -0.67. In the year 2011, what is the difference between the Imports(as % of merchandise exports) of Canada and Imports(as % of merchandise exports) of Philippines?
Offer a terse response. 0.28. In the year 2011, what is the difference between the Imports(as % of merchandise exports) of Canada and Imports(as % of merchandise exports) of Switzerland?
Offer a very short reply. 0.11. In the year 2011, what is the difference between the Imports(as % of merchandise exports) of Lithuania and Imports(as % of merchandise exports) of Philippines?
Provide a succinct answer. 0.96. In the year 2011, what is the difference between the Imports(as % of merchandise exports) in Lithuania and Imports(as % of merchandise exports) in Switzerland?
Give a very brief answer. 0.78. In the year 2011, what is the difference between the Imports(as % of merchandise exports) in Philippines and Imports(as % of merchandise exports) in Switzerland?
Keep it short and to the point. -0.17. In the year 2012, what is the difference between the Imports(as % of merchandise exports) of Canada and Imports(as % of merchandise exports) of Lithuania?
Offer a terse response. -0.72. In the year 2012, what is the difference between the Imports(as % of merchandise exports) in Canada and Imports(as % of merchandise exports) in Philippines?
Provide a short and direct response. 0.3. In the year 2012, what is the difference between the Imports(as % of merchandise exports) of Canada and Imports(as % of merchandise exports) of Switzerland?
Offer a terse response. 0.11. In the year 2012, what is the difference between the Imports(as % of merchandise exports) in Lithuania and Imports(as % of merchandise exports) in Philippines?
Make the answer very short. 1.03. In the year 2012, what is the difference between the Imports(as % of merchandise exports) of Lithuania and Imports(as % of merchandise exports) of Switzerland?
Give a very brief answer. 0.83. In the year 2012, what is the difference between the Imports(as % of merchandise exports) of Philippines and Imports(as % of merchandise exports) of Switzerland?
Your answer should be very brief. -0.19. What is the ratio of the Imports(as % of merchandise exports) of Canada in 2006 to that in 2007?
Give a very brief answer. 1.07. What is the ratio of the Imports(as % of merchandise exports) of Philippines in 2006 to that in 2007?
Offer a very short reply. 1.05. What is the ratio of the Imports(as % of merchandise exports) of Switzerland in 2006 to that in 2007?
Give a very brief answer. 1.01. What is the ratio of the Imports(as % of merchandise exports) of Canada in 2006 to that in 2008?
Ensure brevity in your answer.  1.14. What is the ratio of the Imports(as % of merchandise exports) of Lithuania in 2006 to that in 2008?
Offer a terse response. 1.37. What is the ratio of the Imports(as % of merchandise exports) in Philippines in 2006 to that in 2008?
Make the answer very short. 1.08. What is the ratio of the Imports(as % of merchandise exports) of Switzerland in 2006 to that in 2008?
Ensure brevity in your answer.  1.04. What is the ratio of the Imports(as % of merchandise exports) of Canada in 2006 to that in 2009?
Ensure brevity in your answer.  1.14. What is the ratio of the Imports(as % of merchandise exports) of Lithuania in 2006 to that in 2009?
Give a very brief answer. 1.19. What is the ratio of the Imports(as % of merchandise exports) of Philippines in 2006 to that in 2009?
Provide a short and direct response. 1.14. What is the ratio of the Imports(as % of merchandise exports) of Switzerland in 2006 to that in 2009?
Your response must be concise. 1.05. What is the ratio of the Imports(as % of merchandise exports) in Canada in 2006 to that in 2010?
Ensure brevity in your answer.  1.1. What is the ratio of the Imports(as % of merchandise exports) of Lithuania in 2006 to that in 2010?
Keep it short and to the point. 1.17. What is the ratio of the Imports(as % of merchandise exports) in Philippines in 2006 to that in 2010?
Provide a succinct answer. 1.22. What is the ratio of the Imports(as % of merchandise exports) of Switzerland in 2006 to that in 2010?
Your response must be concise. 1.03. What is the ratio of the Imports(as % of merchandise exports) in Canada in 2006 to that in 2011?
Offer a terse response. 1.1. What is the ratio of the Imports(as % of merchandise exports) of Lithuania in 2006 to that in 2011?
Provide a succinct answer. 1.15. What is the ratio of the Imports(as % of merchandise exports) in Philippines in 2006 to that in 2011?
Provide a short and direct response. 1.07. What is the ratio of the Imports(as % of merchandise exports) in Switzerland in 2006 to that in 2011?
Ensure brevity in your answer.  1.15. What is the ratio of the Imports(as % of merchandise exports) in Canada in 2006 to that in 2012?
Give a very brief answer. 1.17. What is the ratio of the Imports(as % of merchandise exports) of Lithuania in 2006 to that in 2012?
Offer a terse response. 1.16. What is the ratio of the Imports(as % of merchandise exports) in Philippines in 2006 to that in 2012?
Offer a very short reply. 1.21. What is the ratio of the Imports(as % of merchandise exports) in Switzerland in 2006 to that in 2012?
Offer a terse response. 1.23. What is the ratio of the Imports(as % of merchandise exports) in Canada in 2007 to that in 2008?
Provide a succinct answer. 1.06. What is the ratio of the Imports(as % of merchandise exports) of Lithuania in 2007 to that in 2008?
Make the answer very short. 1.37. What is the ratio of the Imports(as % of merchandise exports) in Philippines in 2007 to that in 2008?
Offer a terse response. 1.04. What is the ratio of the Imports(as % of merchandise exports) in Switzerland in 2007 to that in 2008?
Provide a succinct answer. 1.03. What is the ratio of the Imports(as % of merchandise exports) of Canada in 2007 to that in 2009?
Offer a terse response. 1.07. What is the ratio of the Imports(as % of merchandise exports) in Lithuania in 2007 to that in 2009?
Offer a very short reply. 1.19. What is the ratio of the Imports(as % of merchandise exports) in Philippines in 2007 to that in 2009?
Ensure brevity in your answer.  1.09. What is the ratio of the Imports(as % of merchandise exports) of Switzerland in 2007 to that in 2009?
Provide a short and direct response. 1.05. What is the ratio of the Imports(as % of merchandise exports) of Canada in 2007 to that in 2010?
Your answer should be very brief. 1.02. What is the ratio of the Imports(as % of merchandise exports) of Lithuania in 2007 to that in 2010?
Offer a terse response. 1.18. What is the ratio of the Imports(as % of merchandise exports) of Philippines in 2007 to that in 2010?
Give a very brief answer. 1.16. What is the ratio of the Imports(as % of merchandise exports) in Switzerland in 2007 to that in 2010?
Make the answer very short. 1.03. What is the ratio of the Imports(as % of merchandise exports) in Canada in 2007 to that in 2011?
Provide a succinct answer. 1.03. What is the ratio of the Imports(as % of merchandise exports) of Lithuania in 2007 to that in 2011?
Your answer should be compact. 1.15. What is the ratio of the Imports(as % of merchandise exports) of Philippines in 2007 to that in 2011?
Offer a terse response. 1.03. What is the ratio of the Imports(as % of merchandise exports) in Switzerland in 2007 to that in 2011?
Make the answer very short. 1.14. What is the ratio of the Imports(as % of merchandise exports) of Canada in 2007 to that in 2012?
Your answer should be compact. 1.09. What is the ratio of the Imports(as % of merchandise exports) of Lithuania in 2007 to that in 2012?
Your answer should be compact. 1.16. What is the ratio of the Imports(as % of merchandise exports) of Philippines in 2007 to that in 2012?
Keep it short and to the point. 1.16. What is the ratio of the Imports(as % of merchandise exports) in Switzerland in 2007 to that in 2012?
Provide a succinct answer. 1.23. What is the ratio of the Imports(as % of merchandise exports) of Lithuania in 2008 to that in 2009?
Provide a succinct answer. 0.87. What is the ratio of the Imports(as % of merchandise exports) of Philippines in 2008 to that in 2009?
Keep it short and to the point. 1.05. What is the ratio of the Imports(as % of merchandise exports) in Switzerland in 2008 to that in 2009?
Your response must be concise. 1.01. What is the ratio of the Imports(as % of merchandise exports) of Lithuania in 2008 to that in 2010?
Give a very brief answer. 0.86. What is the ratio of the Imports(as % of merchandise exports) of Philippines in 2008 to that in 2010?
Provide a succinct answer. 1.12. What is the ratio of the Imports(as % of merchandise exports) of Canada in 2008 to that in 2011?
Make the answer very short. 0.96. What is the ratio of the Imports(as % of merchandise exports) in Lithuania in 2008 to that in 2011?
Ensure brevity in your answer.  0.84. What is the ratio of the Imports(as % of merchandise exports) of Philippines in 2008 to that in 2011?
Offer a terse response. 0.99. What is the ratio of the Imports(as % of merchandise exports) in Switzerland in 2008 to that in 2011?
Make the answer very short. 1.1. What is the ratio of the Imports(as % of merchandise exports) in Canada in 2008 to that in 2012?
Your answer should be very brief. 1.03. What is the ratio of the Imports(as % of merchandise exports) in Lithuania in 2008 to that in 2012?
Your answer should be compact. 0.85. What is the ratio of the Imports(as % of merchandise exports) in Philippines in 2008 to that in 2012?
Keep it short and to the point. 1.11. What is the ratio of the Imports(as % of merchandise exports) in Switzerland in 2008 to that in 2012?
Ensure brevity in your answer.  1.19. What is the ratio of the Imports(as % of merchandise exports) in Canada in 2009 to that in 2010?
Offer a very short reply. 0.96. What is the ratio of the Imports(as % of merchandise exports) in Lithuania in 2009 to that in 2010?
Offer a terse response. 0.98. What is the ratio of the Imports(as % of merchandise exports) of Philippines in 2009 to that in 2010?
Your answer should be compact. 1.07. What is the ratio of the Imports(as % of merchandise exports) of Switzerland in 2009 to that in 2010?
Keep it short and to the point. 0.98. What is the ratio of the Imports(as % of merchandise exports) of Lithuania in 2009 to that in 2011?
Provide a short and direct response. 0.97. What is the ratio of the Imports(as % of merchandise exports) of Philippines in 2009 to that in 2011?
Offer a very short reply. 0.94. What is the ratio of the Imports(as % of merchandise exports) in Switzerland in 2009 to that in 2011?
Provide a succinct answer. 1.09. What is the ratio of the Imports(as % of merchandise exports) in Canada in 2009 to that in 2012?
Your answer should be very brief. 1.02. What is the ratio of the Imports(as % of merchandise exports) of Lithuania in 2009 to that in 2012?
Make the answer very short. 0.97. What is the ratio of the Imports(as % of merchandise exports) in Philippines in 2009 to that in 2012?
Your response must be concise. 1.06. What is the ratio of the Imports(as % of merchandise exports) in Switzerland in 2009 to that in 2012?
Ensure brevity in your answer.  1.17. What is the ratio of the Imports(as % of merchandise exports) in Canada in 2010 to that in 2011?
Provide a short and direct response. 1. What is the ratio of the Imports(as % of merchandise exports) of Lithuania in 2010 to that in 2011?
Offer a very short reply. 0.98. What is the ratio of the Imports(as % of merchandise exports) in Philippines in 2010 to that in 2011?
Make the answer very short. 0.88. What is the ratio of the Imports(as % of merchandise exports) in Switzerland in 2010 to that in 2011?
Provide a succinct answer. 1.11. What is the ratio of the Imports(as % of merchandise exports) in Canada in 2010 to that in 2012?
Offer a very short reply. 1.06. What is the ratio of the Imports(as % of merchandise exports) of Lithuania in 2010 to that in 2012?
Make the answer very short. 0.99. What is the ratio of the Imports(as % of merchandise exports) in Philippines in 2010 to that in 2012?
Ensure brevity in your answer.  0.99. What is the ratio of the Imports(as % of merchandise exports) of Switzerland in 2010 to that in 2012?
Give a very brief answer. 1.2. What is the ratio of the Imports(as % of merchandise exports) in Canada in 2011 to that in 2012?
Your answer should be very brief. 1.06. What is the ratio of the Imports(as % of merchandise exports) in Philippines in 2011 to that in 2012?
Provide a short and direct response. 1.13. What is the ratio of the Imports(as % of merchandise exports) of Switzerland in 2011 to that in 2012?
Keep it short and to the point. 1.08. What is the difference between the highest and the second highest Imports(as % of merchandise exports) of Canada?
Your answer should be very brief. 0.07. What is the difference between the highest and the second highest Imports(as % of merchandise exports) in Lithuania?
Offer a very short reply. 0.01. What is the difference between the highest and the second highest Imports(as % of merchandise exports) in Philippines?
Offer a terse response. 0.03. What is the difference between the highest and the second highest Imports(as % of merchandise exports) in Switzerland?
Make the answer very short. 0.01. What is the difference between the highest and the lowest Imports(as % of merchandise exports) in Canada?
Your answer should be very brief. 0.16. What is the difference between the highest and the lowest Imports(as % of merchandise exports) in Lithuania?
Ensure brevity in your answer.  0.53. What is the difference between the highest and the lowest Imports(as % of merchandise exports) of Philippines?
Offer a very short reply. 0.14. What is the difference between the highest and the lowest Imports(as % of merchandise exports) of Switzerland?
Your answer should be compact. 0.2. 